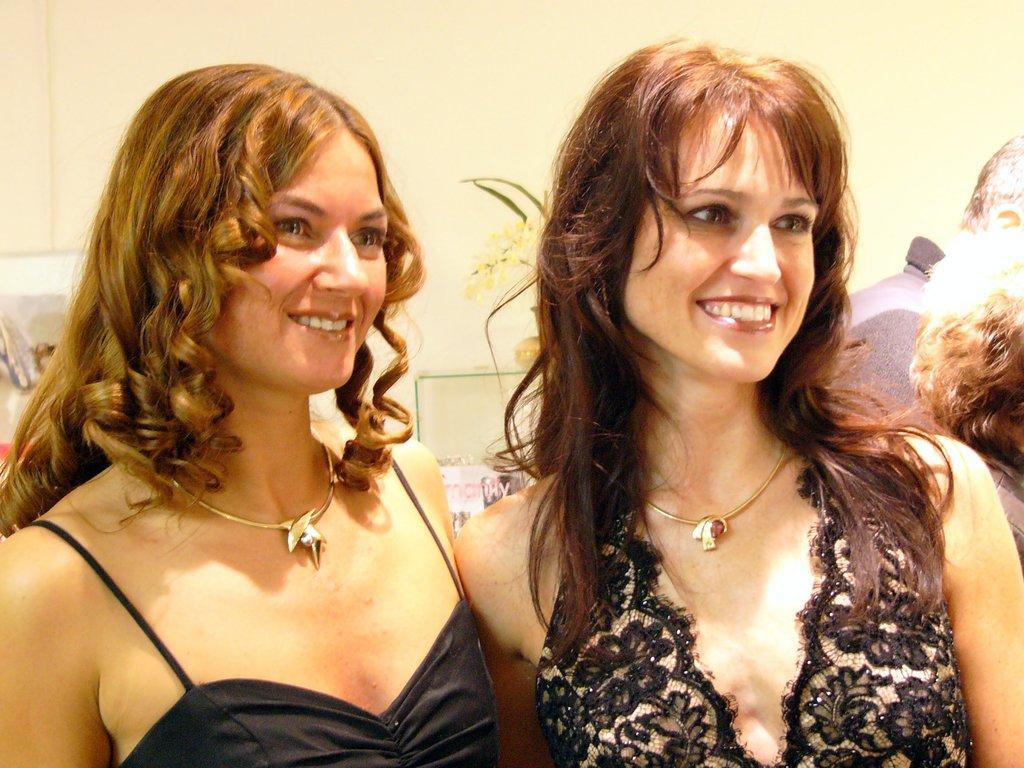How would you summarize this image in a sentence or two? In this image we can see few persons. Behind the persons we can see few objects and the wall. 